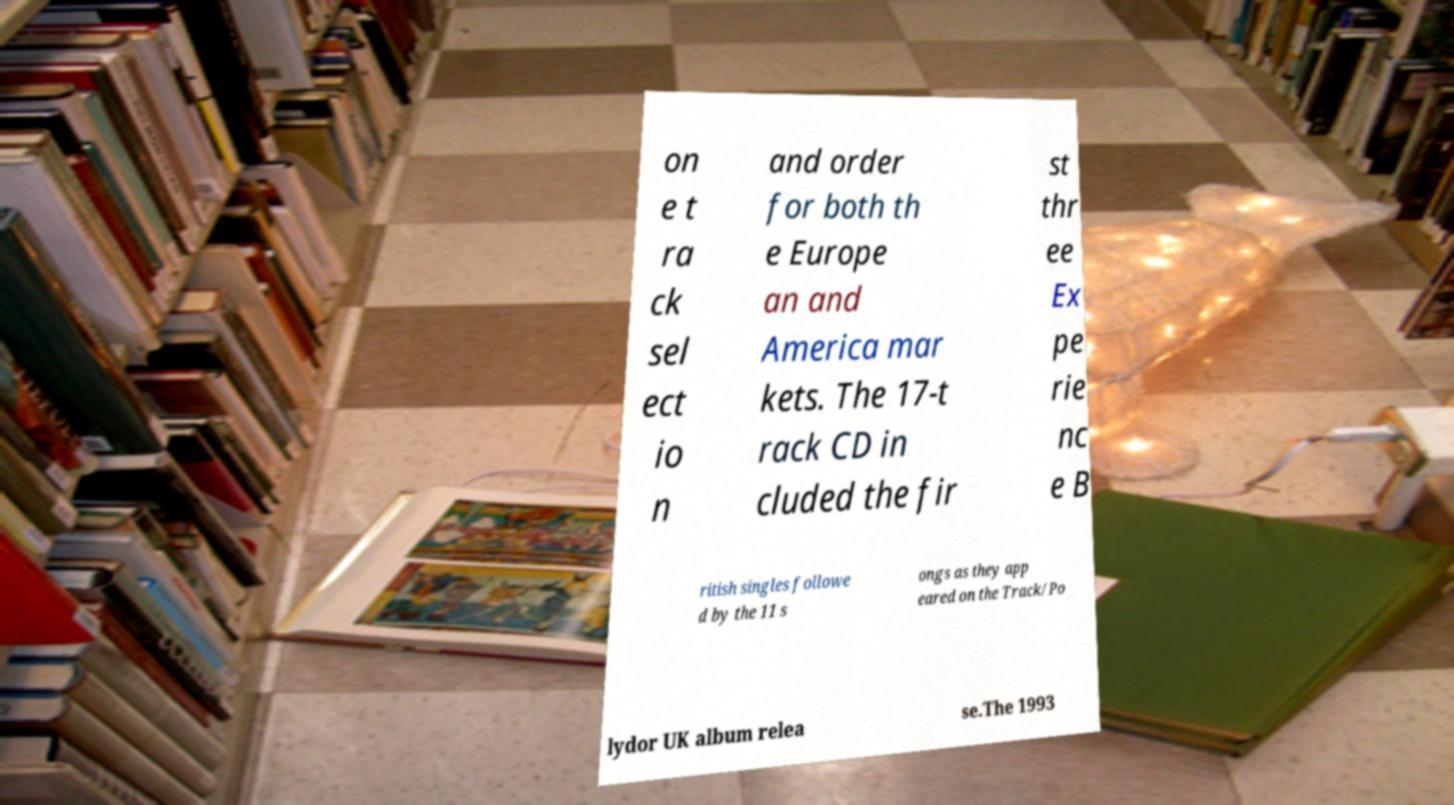Please identify and transcribe the text found in this image. on e t ra ck sel ect io n and order for both th e Europe an and America mar kets. The 17-t rack CD in cluded the fir st thr ee Ex pe rie nc e B ritish singles followe d by the 11 s ongs as they app eared on the Track/Po lydor UK album relea se.The 1993 